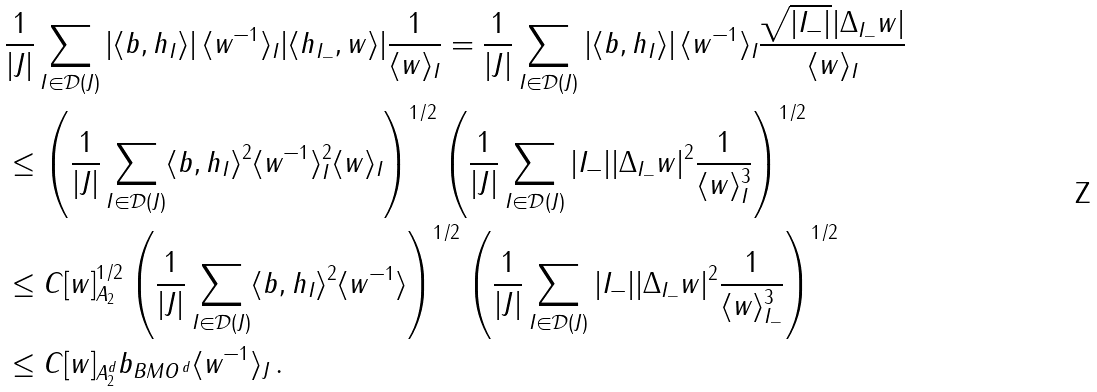<formula> <loc_0><loc_0><loc_500><loc_500>& \frac { 1 } { | J | } \sum _ { I \in \mathcal { D } ( J ) } | \langle b , h _ { I } \rangle | \, \langle w ^ { - 1 } \rangle _ { I } | \langle h _ { I _ { - } } , w \rangle | \frac { 1 } { \langle w \rangle _ { I } } = \frac { 1 } { | J | } \sum _ { I \in \mathcal { D } ( J ) } | \langle b , h _ { I } \rangle | \, \langle w ^ { - 1 } \rangle _ { I } \frac { \sqrt { | I _ { - } | } | \Delta _ { I _ { - } } w | } { \langle w \rangle _ { I } } \\ & \leq \left ( \frac { 1 } { | J | } \sum _ { I \in \mathcal { D } ( J ) } \langle b , h _ { I } \rangle ^ { 2 } \langle w ^ { - 1 } \rangle ^ { 2 } _ { I } \langle w \rangle _ { I } \right ) ^ { 1 / 2 } \left ( \frac { 1 } { | J | } \sum _ { I \in \mathcal { D } ( J ) } | I _ { - } | | \Delta _ { I _ { - } } w | ^ { 2 } \frac { 1 } { \langle w \rangle _ { I } ^ { 3 } } \right ) ^ { 1 / 2 } \\ & \leq C [ w ] ^ { 1 / 2 } _ { A _ { 2 } } \left ( \frac { 1 } { | J | } \sum _ { I \in \mathcal { D } ( J ) } \langle b , h _ { I } \rangle ^ { 2 } \langle w ^ { - 1 } \rangle \right ) ^ { 1 / 2 } \left ( \frac { 1 } { | J | } \sum _ { I \in \mathcal { D } ( J ) } | I _ { - } | | \Delta _ { I _ { - } } w | ^ { 2 } \frac { 1 } { \langle w \rangle _ { I _ { - } } ^ { 3 } } \right ) ^ { 1 / 2 } \\ & \leq C [ w ] _ { A ^ { d } _ { 2 } } \| b \| _ { B M O ^ { \, d } } \langle w ^ { - 1 } \rangle _ { J } \, .</formula> 